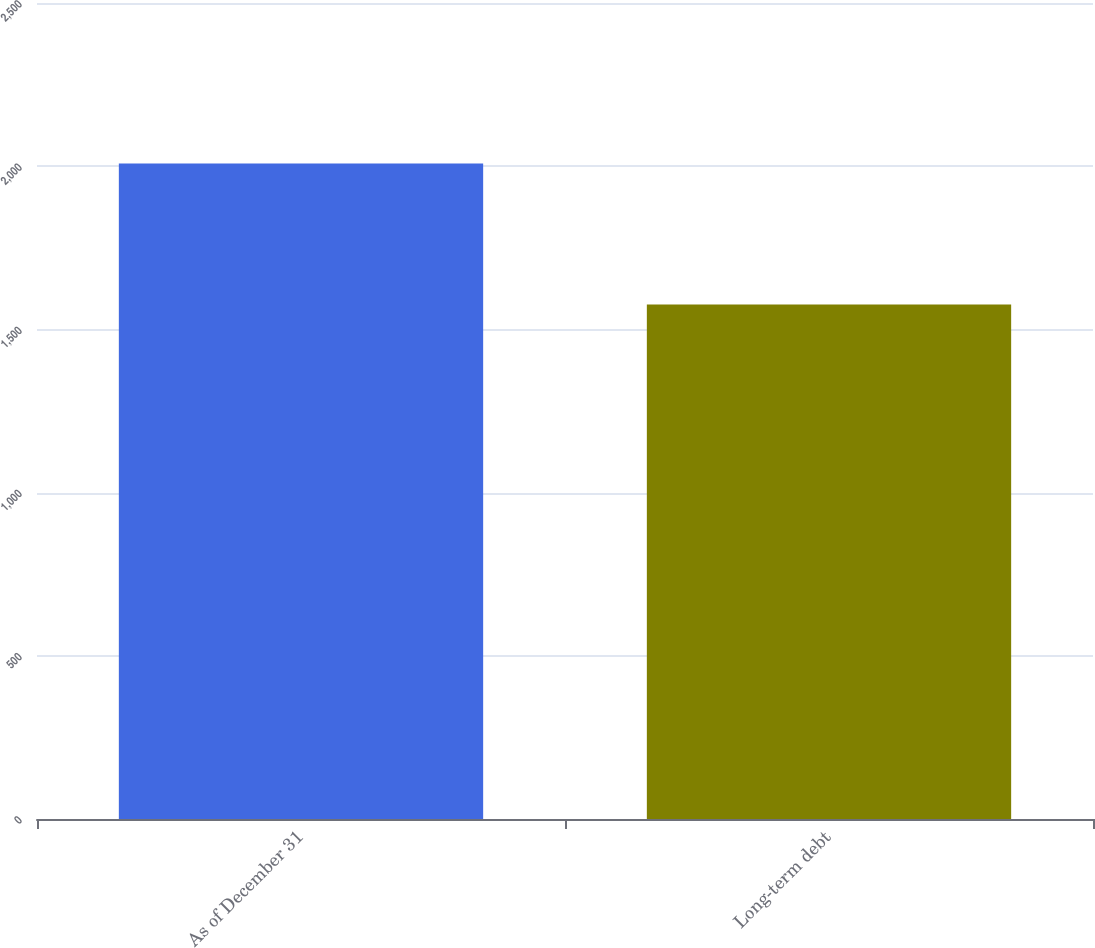Convert chart. <chart><loc_0><loc_0><loc_500><loc_500><bar_chart><fcel>As of December 31<fcel>Long-term debt<nl><fcel>2008<fcel>1576<nl></chart> 